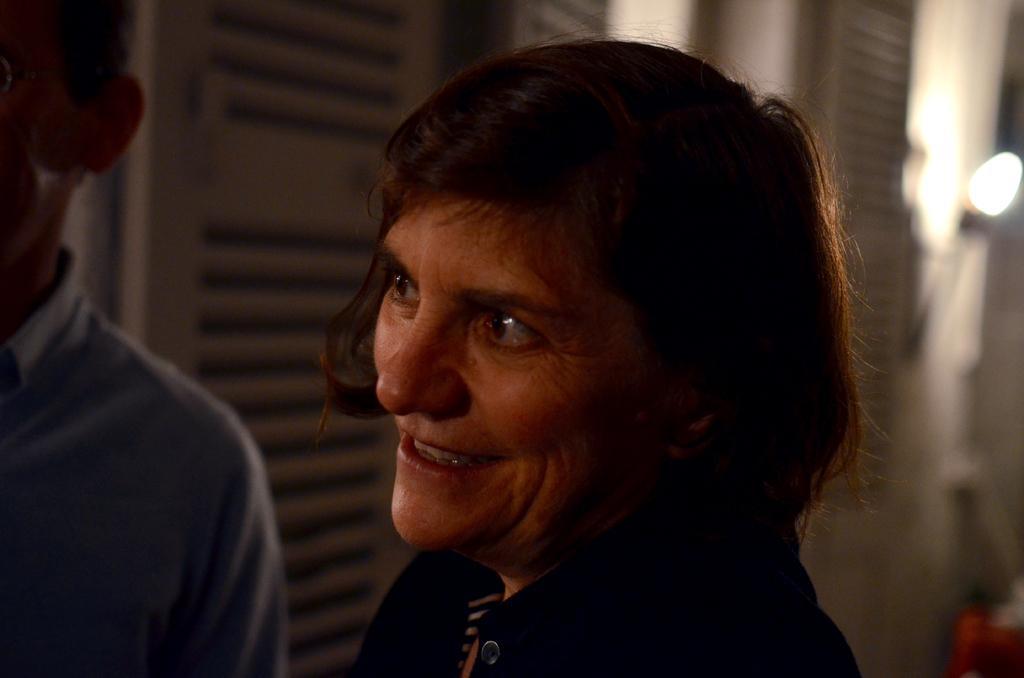Could you give a brief overview of what you see in this image? In this image, I can see the woman smiling. On the left side of the image, I can see another person standing. In the background, I think these are the doors. 